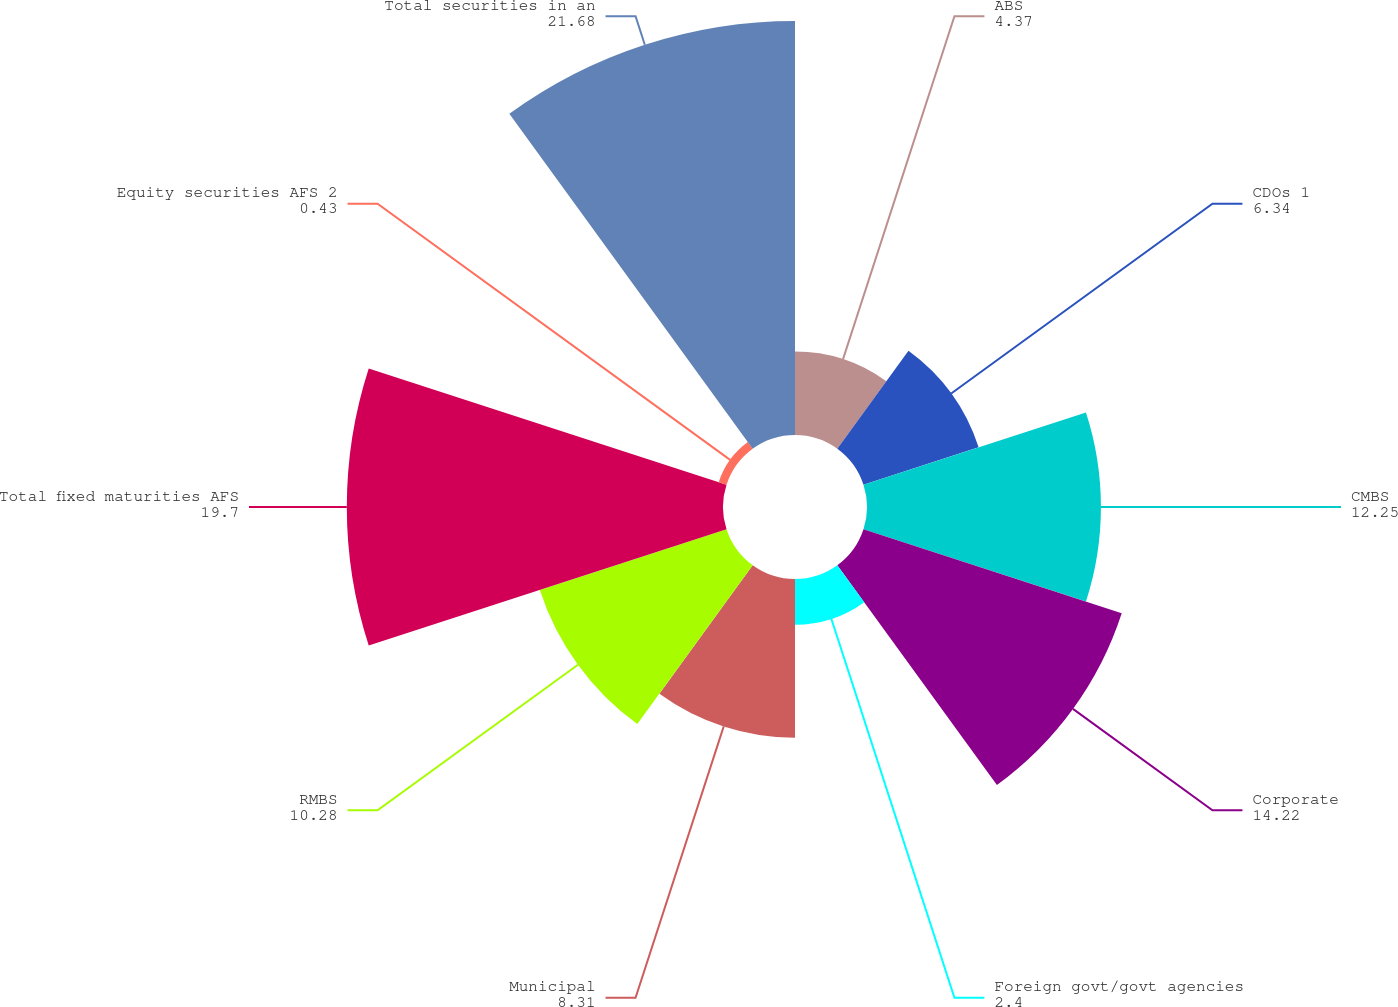Convert chart. <chart><loc_0><loc_0><loc_500><loc_500><pie_chart><fcel>ABS<fcel>CDOs 1<fcel>CMBS<fcel>Corporate<fcel>Foreign govt/govt agencies<fcel>Municipal<fcel>RMBS<fcel>Total fixed maturities AFS<fcel>Equity securities AFS 2<fcel>Total securities in an<nl><fcel>4.37%<fcel>6.34%<fcel>12.25%<fcel>14.22%<fcel>2.4%<fcel>8.31%<fcel>10.28%<fcel>19.7%<fcel>0.43%<fcel>21.68%<nl></chart> 